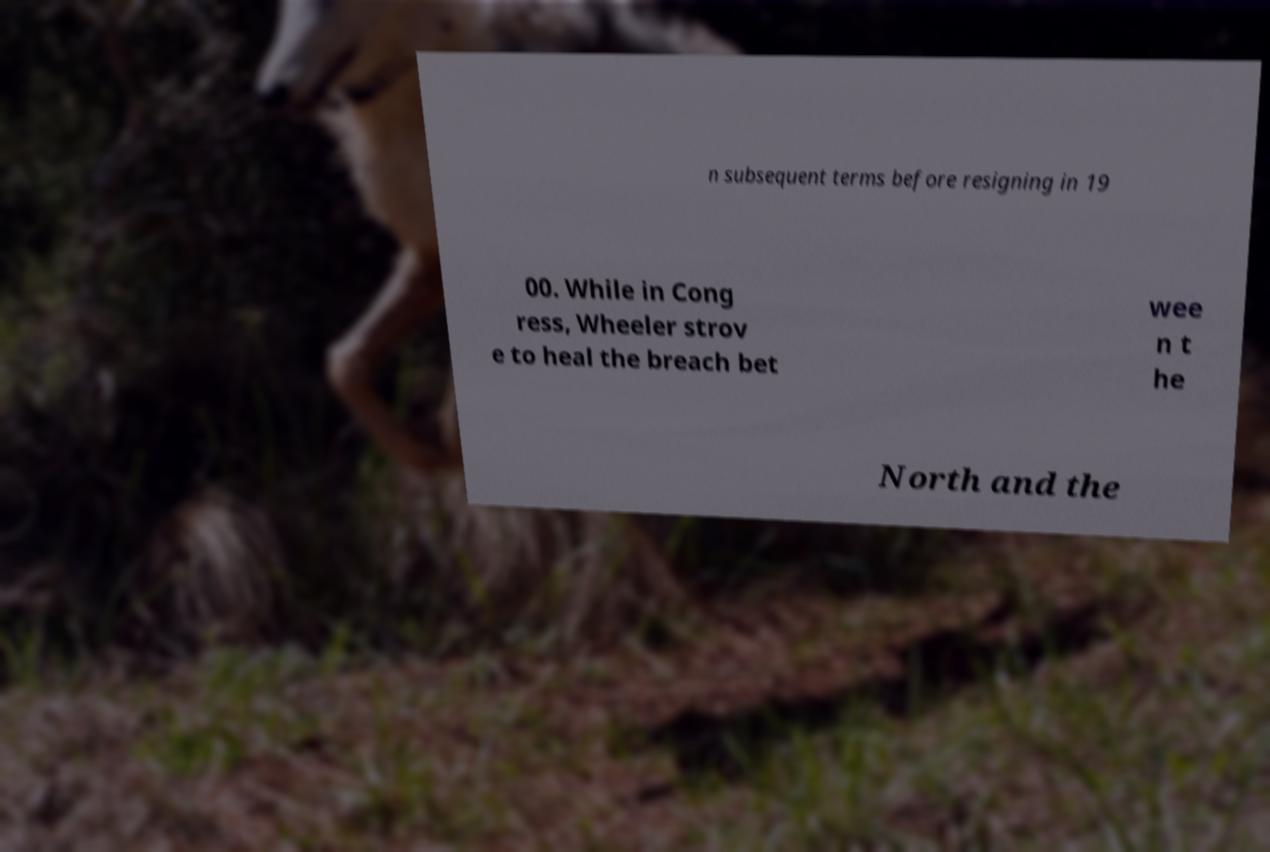Could you extract and type out the text from this image? n subsequent terms before resigning in 19 00. While in Cong ress, Wheeler strov e to heal the breach bet wee n t he North and the 